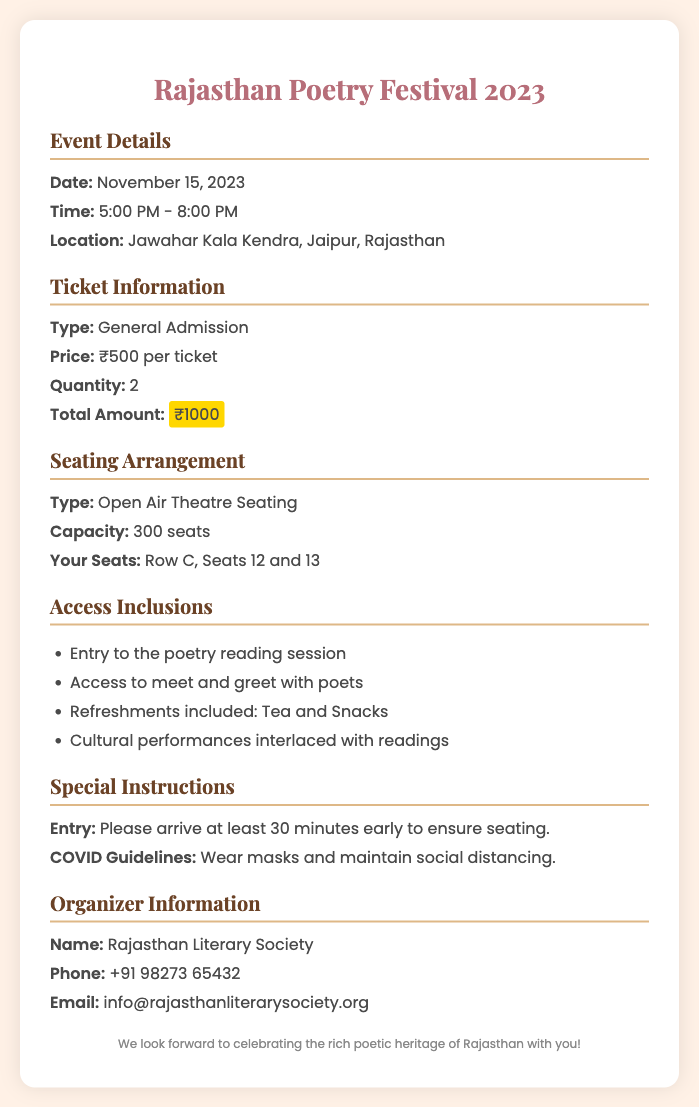what is the date of the event? The date of the event is clearly listed in the document under event details.
Answer: November 15, 2023 what time does the event start? The start time is mentioned in the event details section of the document.
Answer: 5:00 PM how many tickets were purchased? The quantity of tickets is specified in the ticket information section.
Answer: 2 what is the seating type for the event? The seating type is outlined in the seating arrangement section.
Answer: Open Air Theatre Seating who is organizing the event? The organizer's name is provided in the organizer information section.
Answer: Rajasthan Literary Society what is included in the access details? The access inclusions contain multiple items, which are listed as benefits for attendees.
Answer: Entry to the poetry reading session, Access to meet and greet with poets, Refreshments included: Tea and Snacks, Cultural performances interlaced with readings how much is the total amount for the tickets? The total amount is specified in the ticket information section.
Answer: ₹1000 what is the capacity of the seating? The capacity of the seating arrangement is stated in the seating details section.
Answer: 300 seats what special instructions are mentioned for entry? Special instructions are provided in the document regarding the entry process.
Answer: Please arrive at least 30 minutes early to ensure seating 